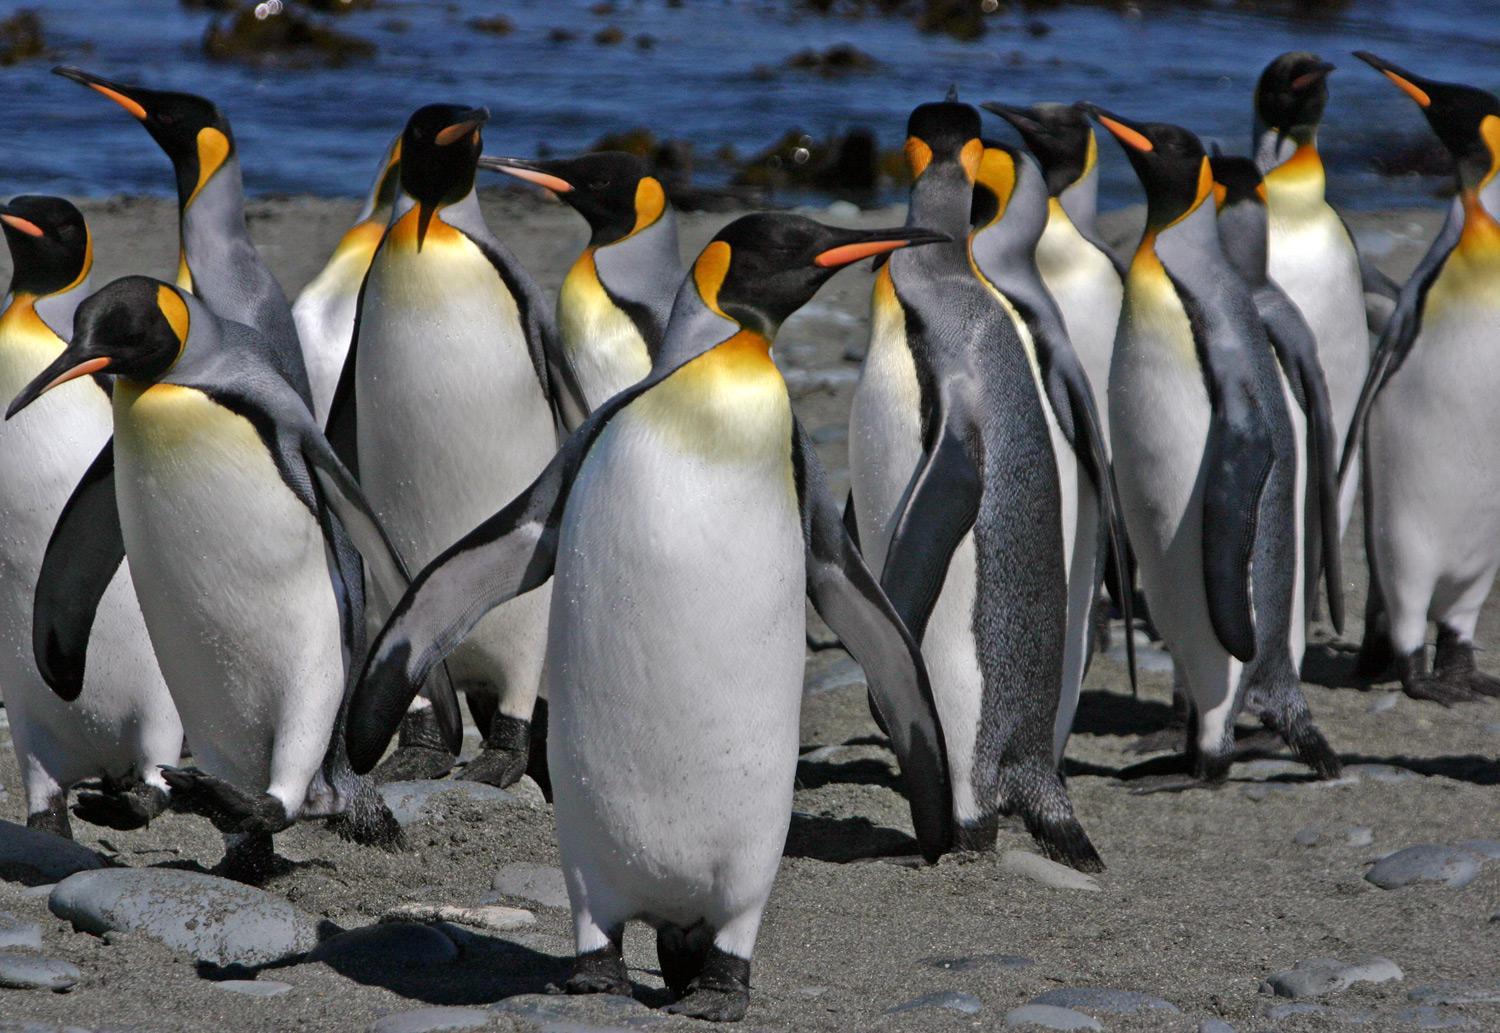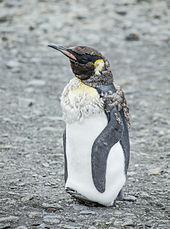The first image is the image on the left, the second image is the image on the right. Given the left and right images, does the statement "Each image contains one standing penguin, and all penguins have heads turned rightward." hold true? Answer yes or no. No. The first image is the image on the left, the second image is the image on the right. Analyze the images presented: Is the assertion "There is only one penguin in each image and every penguin looks towards the right." valid? Answer yes or no. No. 